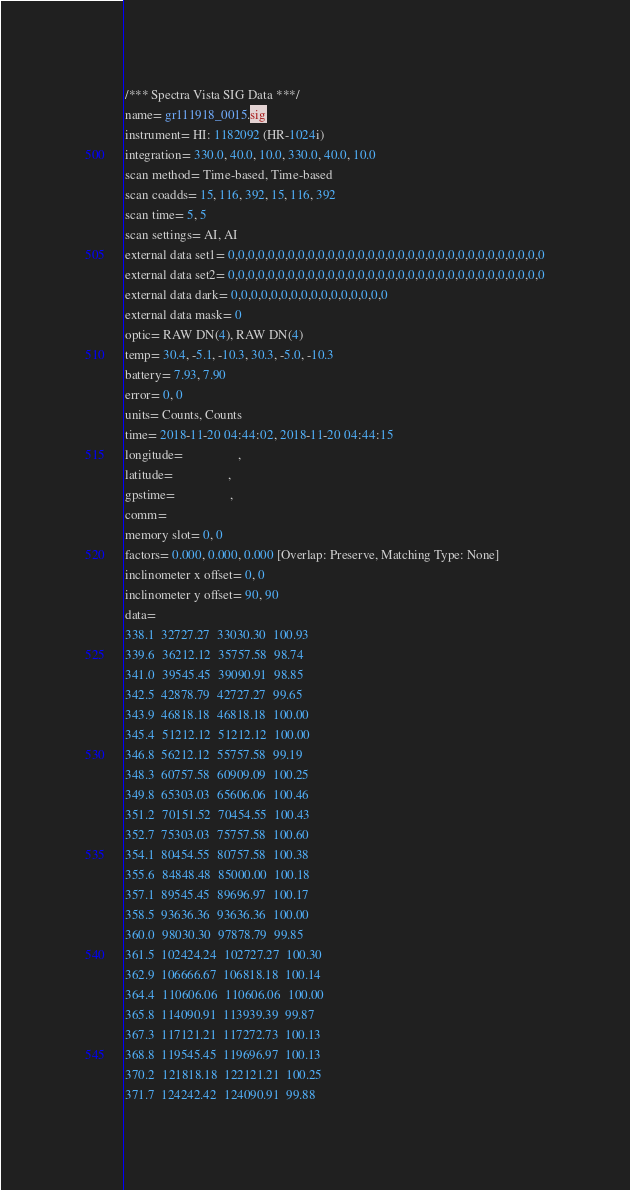<code> <loc_0><loc_0><loc_500><loc_500><_SML_>/*** Spectra Vista SIG Data ***/
name= gr111918_0015.sig
instrument= HI: 1182092 (HR-1024i)
integration= 330.0, 40.0, 10.0, 330.0, 40.0, 10.0
scan method= Time-based, Time-based
scan coadds= 15, 116, 392, 15, 116, 392
scan time= 5, 5
scan settings= AI, AI
external data set1= 0,0,0,0,0,0,0,0,0,0,0,0,0,0,0,0,0,0,0,0,0,0,0,0,0,0,0,0,0,0,0,0
external data set2= 0,0,0,0,0,0,0,0,0,0,0,0,0,0,0,0,0,0,0,0,0,0,0,0,0,0,0,0,0,0,0,0
external data dark= 0,0,0,0,0,0,0,0,0,0,0,0,0,0,0,0
external data mask= 0
optic= RAW DN(4), RAW DN(4)
temp= 30.4, -5.1, -10.3, 30.3, -5.0, -10.3
battery= 7.93, 7.90
error= 0, 0
units= Counts, Counts
time= 2018-11-20 04:44:02, 2018-11-20 04:44:15
longitude=                 ,                 
latitude=                 ,                 
gpstime=                 ,                 
comm= 
memory slot= 0, 0
factors= 0.000, 0.000, 0.000 [Overlap: Preserve, Matching Type: None]
inclinometer x offset= 0, 0
inclinometer y offset= 90, 90
data= 
338.1  32727.27  33030.30  100.93
339.6  36212.12  35757.58  98.74
341.0  39545.45  39090.91  98.85
342.5  42878.79  42727.27  99.65
343.9  46818.18  46818.18  100.00
345.4  51212.12  51212.12  100.00
346.8  56212.12  55757.58  99.19
348.3  60757.58  60909.09  100.25
349.8  65303.03  65606.06  100.46
351.2  70151.52  70454.55  100.43
352.7  75303.03  75757.58  100.60
354.1  80454.55  80757.58  100.38
355.6  84848.48  85000.00  100.18
357.1  89545.45  89696.97  100.17
358.5  93636.36  93636.36  100.00
360.0  98030.30  97878.79  99.85
361.5  102424.24  102727.27  100.30
362.9  106666.67  106818.18  100.14
364.4  110606.06  110606.06  100.00
365.8  114090.91  113939.39  99.87
367.3  117121.21  117272.73  100.13
368.8  119545.45  119696.97  100.13
370.2  121818.18  122121.21  100.25
371.7  124242.42  124090.91  99.88</code> 